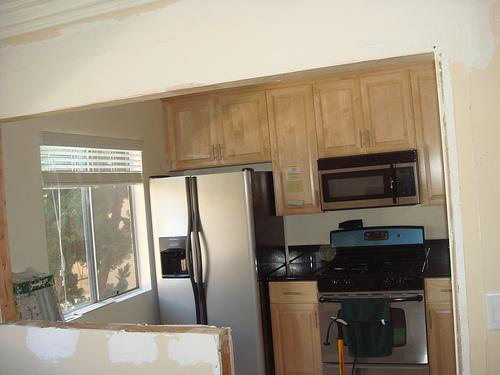Question: how many cabinet panels are pictured?
Choices:
A. Four.
B. Three.
C. Eight.
D. Six.
Answer with the letter. Answer: C Question: what is in front of the stove?
Choices:
A. A bike pump.
B. A kitchen chair.
C. The refrigerator.
D. The cat.
Answer with the letter. Answer: A Question: where is the microwave?
Choices:
A. Above the stove.
B. In the kitchen.
C. On the right hand side.
D. Below the fan.
Answer with the letter. Answer: A Question: what is on the refrigerator?
Choices:
A. A magnet.
B. An icemaker.
C. A picture.
D. A clock.
Answer with the letter. Answer: B 